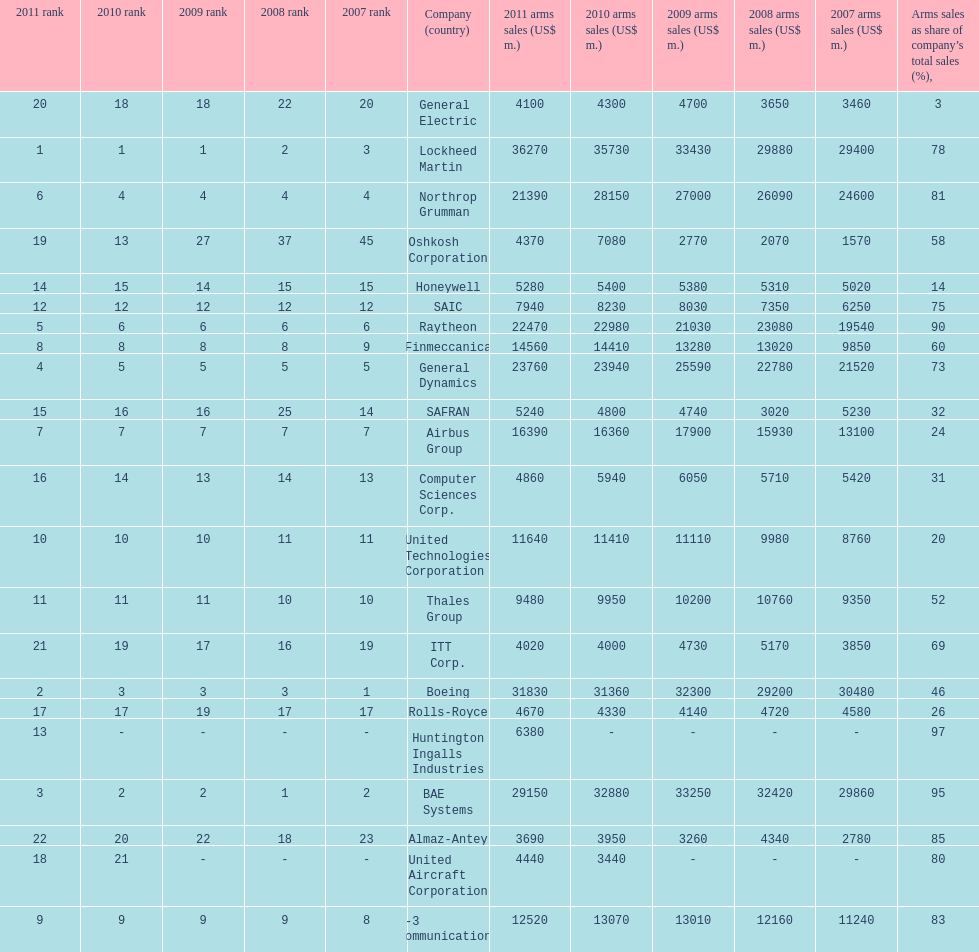Determine the variation between boeing's 2010 arms sales and raytheon's 2010 arms sales. 8380. 